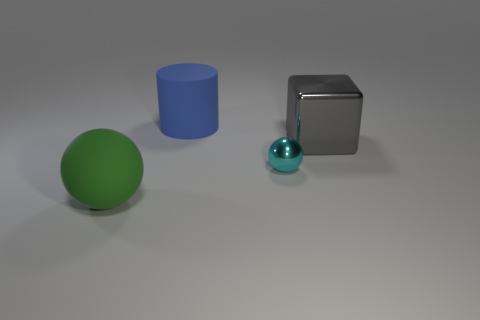There is a rubber object that is in front of the tiny sphere; is its shape the same as the small object?
Your response must be concise. Yes. Are there more metallic cubes that are right of the big blue object than large red shiny objects?
Ensure brevity in your answer.  Yes. There is a thing that is to the left of the tiny metal sphere and behind the cyan sphere; what material is it?
Your answer should be compact. Rubber. Is there any other thing that has the same shape as the blue object?
Offer a terse response. No. How many objects are to the left of the gray object and to the right of the blue rubber thing?
Your answer should be compact. 1. What material is the gray object?
Give a very brief answer. Metal. Is the number of shiny spheres that are behind the blue cylinder the same as the number of gray objects?
Your answer should be very brief. No. What number of other metallic things are the same shape as the tiny object?
Give a very brief answer. 0. Is the green object the same shape as the tiny metallic thing?
Your answer should be compact. Yes. What number of objects are large objects in front of the gray block or large yellow shiny balls?
Your response must be concise. 1. 